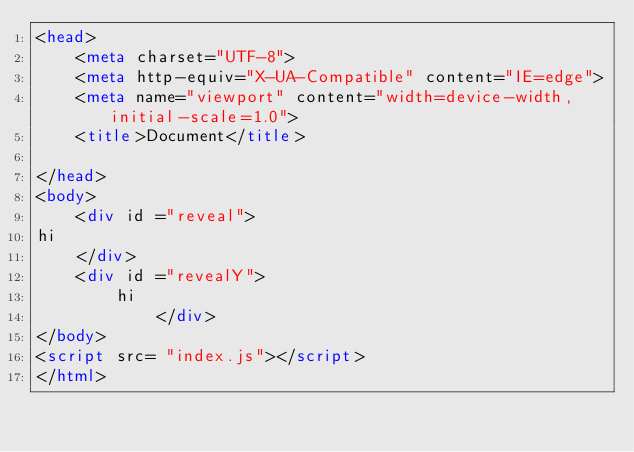<code> <loc_0><loc_0><loc_500><loc_500><_HTML_><head>
    <meta charset="UTF-8">
    <meta http-equiv="X-UA-Compatible" content="IE=edge">
    <meta name="viewport" content="width=device-width, initial-scale=1.0">
    <title>Document</title>

</head>
<body>
    <div id ="reveal">
hi
    </div>
    <div id ="revealY">
        hi
            </div>
</body>
<script src= "index.js"></script>
</html></code> 